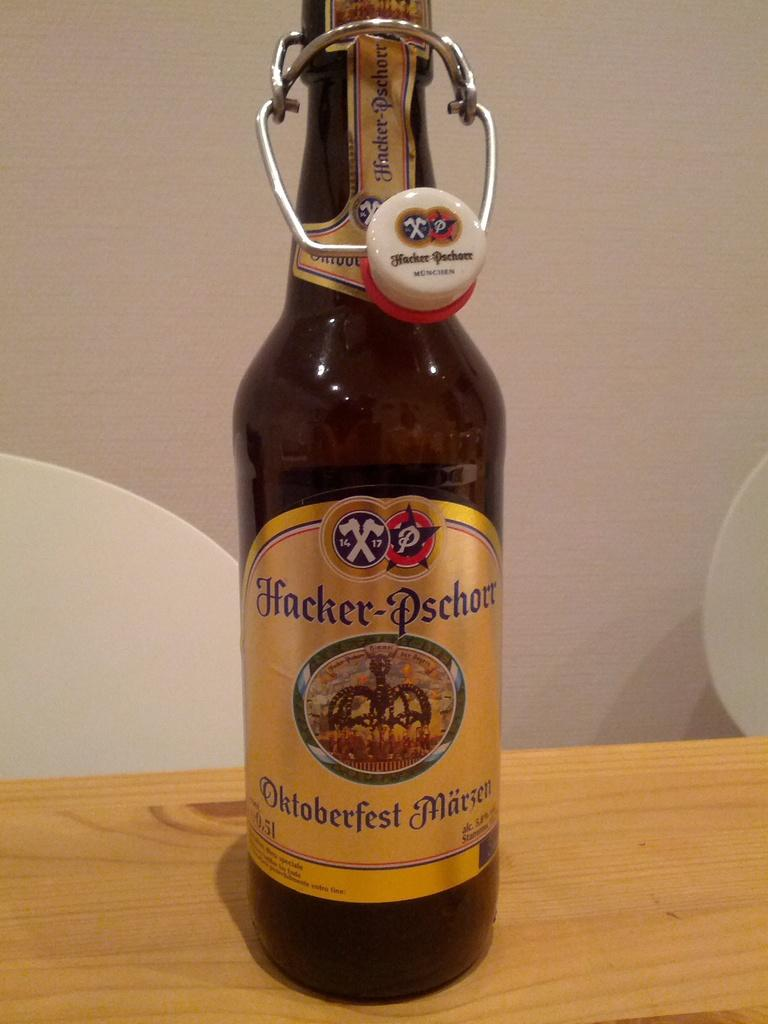<image>
Share a concise interpretation of the image provided. A brown bottle of Hacker-Pschorr on a wooden surface. 